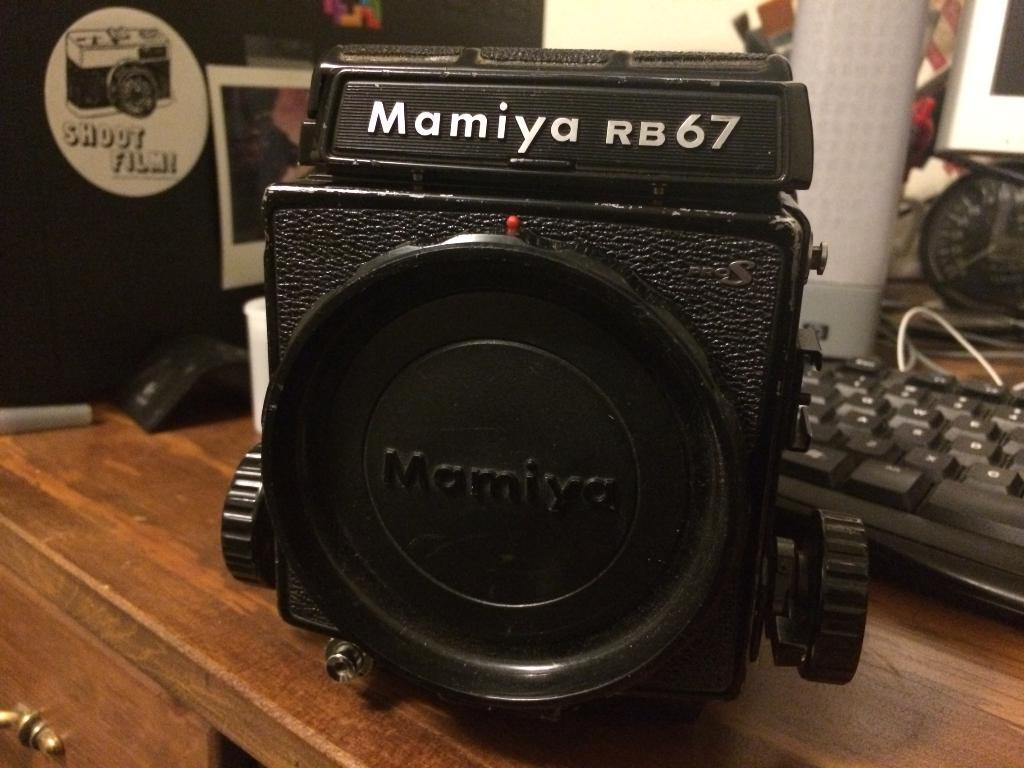<image>
Summarize the visual content of the image. A piece of equipment says Mamiya RB67 on it. 